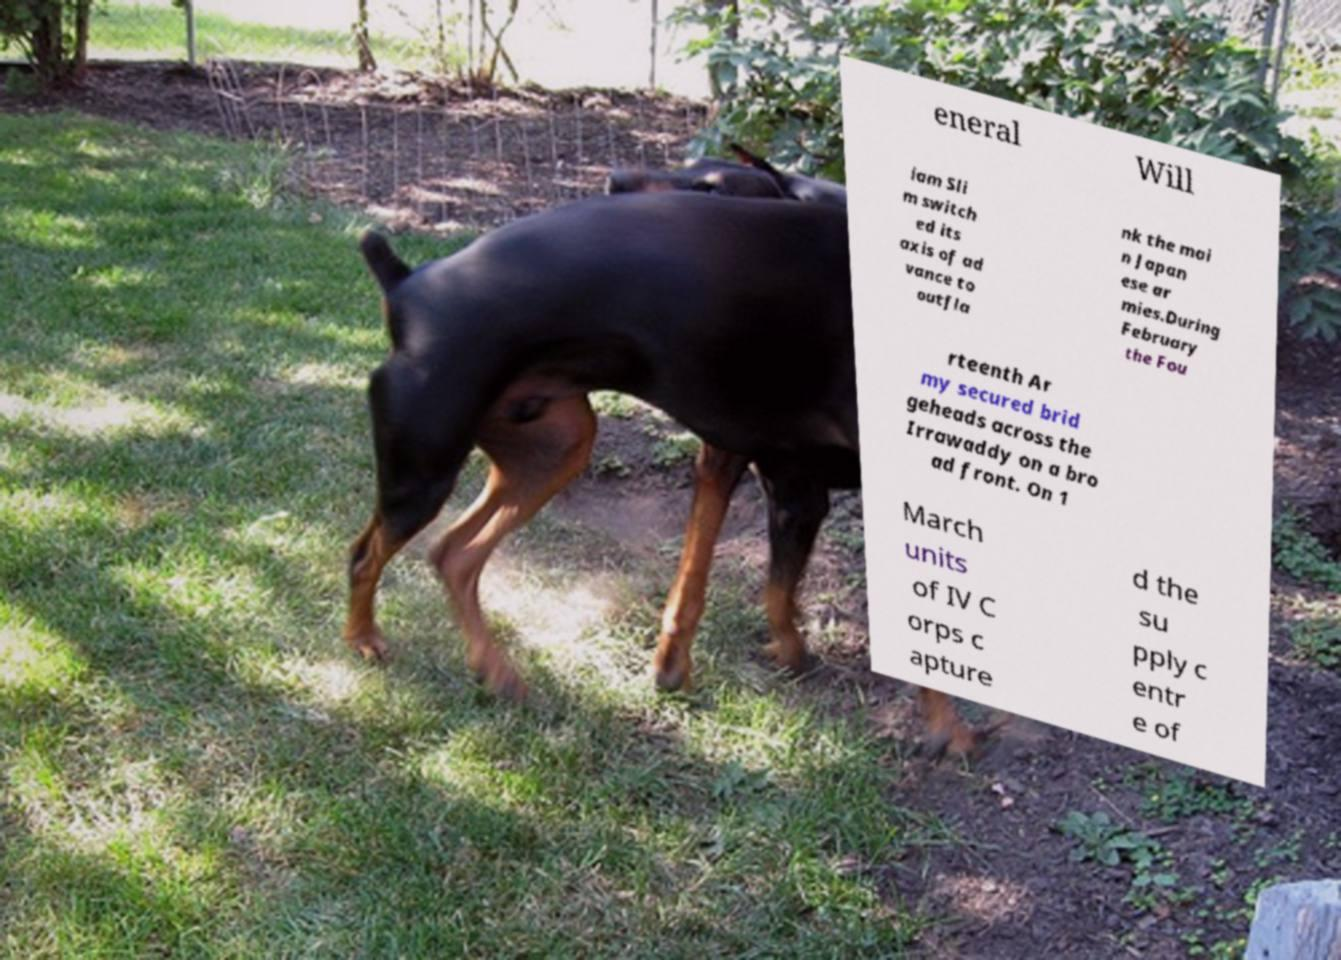There's text embedded in this image that I need extracted. Can you transcribe it verbatim? eneral Will iam Sli m switch ed its axis of ad vance to outfla nk the mai n Japan ese ar mies.During February the Fou rteenth Ar my secured brid geheads across the Irrawaddy on a bro ad front. On 1 March units of IV C orps c apture d the su pply c entr e of 